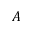Convert formula to latex. <formula><loc_0><loc_0><loc_500><loc_500>A</formula> 